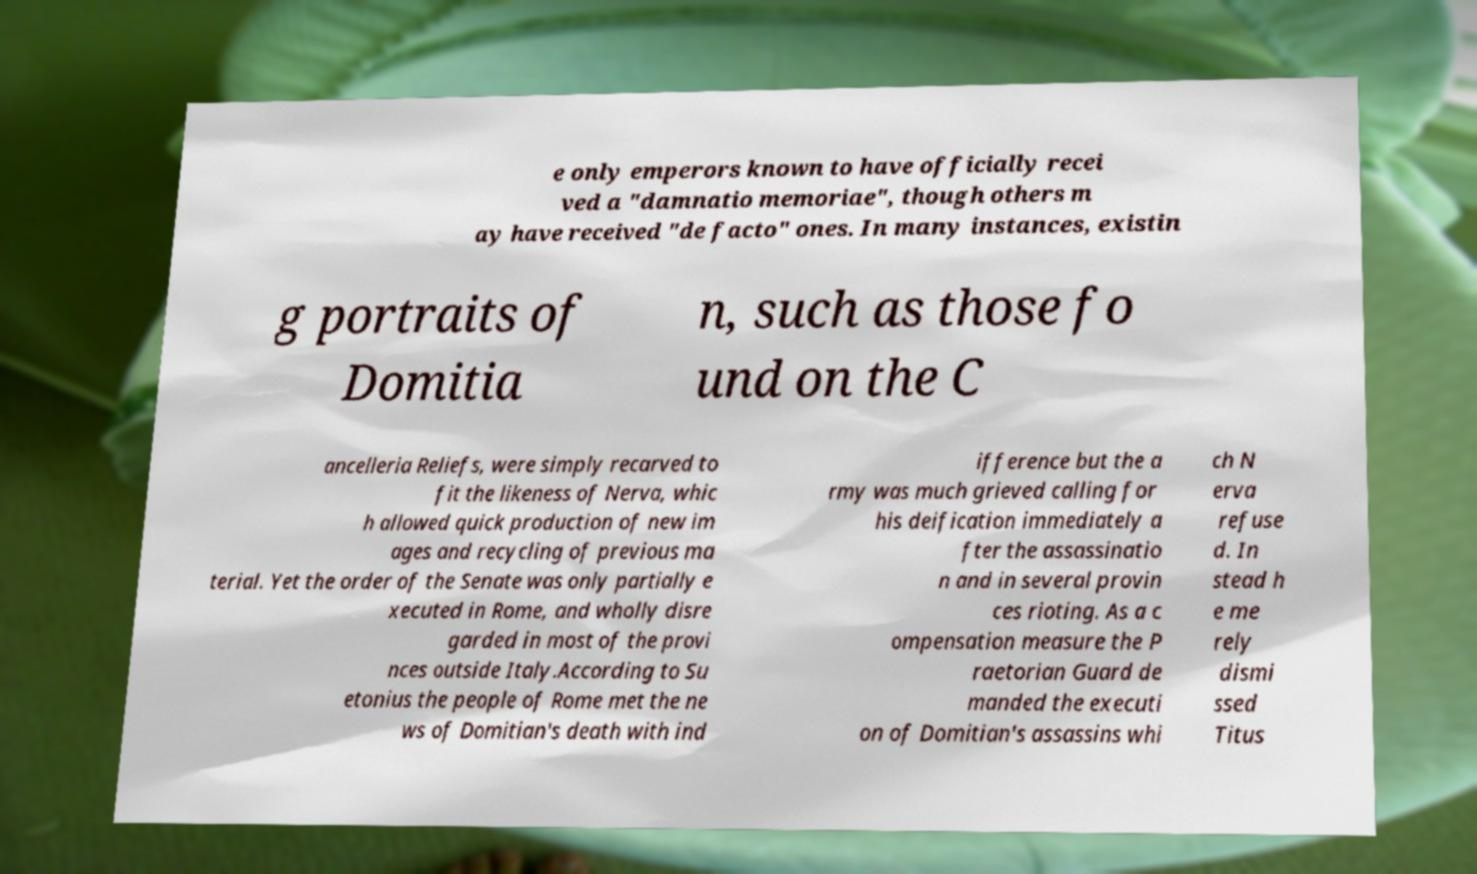What messages or text are displayed in this image? I need them in a readable, typed format. e only emperors known to have officially recei ved a "damnatio memoriae", though others m ay have received "de facto" ones. In many instances, existin g portraits of Domitia n, such as those fo und on the C ancelleria Reliefs, were simply recarved to fit the likeness of Nerva, whic h allowed quick production of new im ages and recycling of previous ma terial. Yet the order of the Senate was only partially e xecuted in Rome, and wholly disre garded in most of the provi nces outside Italy.According to Su etonius the people of Rome met the ne ws of Domitian's death with ind ifference but the a rmy was much grieved calling for his deification immediately a fter the assassinatio n and in several provin ces rioting. As a c ompensation measure the P raetorian Guard de manded the executi on of Domitian's assassins whi ch N erva refuse d. In stead h e me rely dismi ssed Titus 